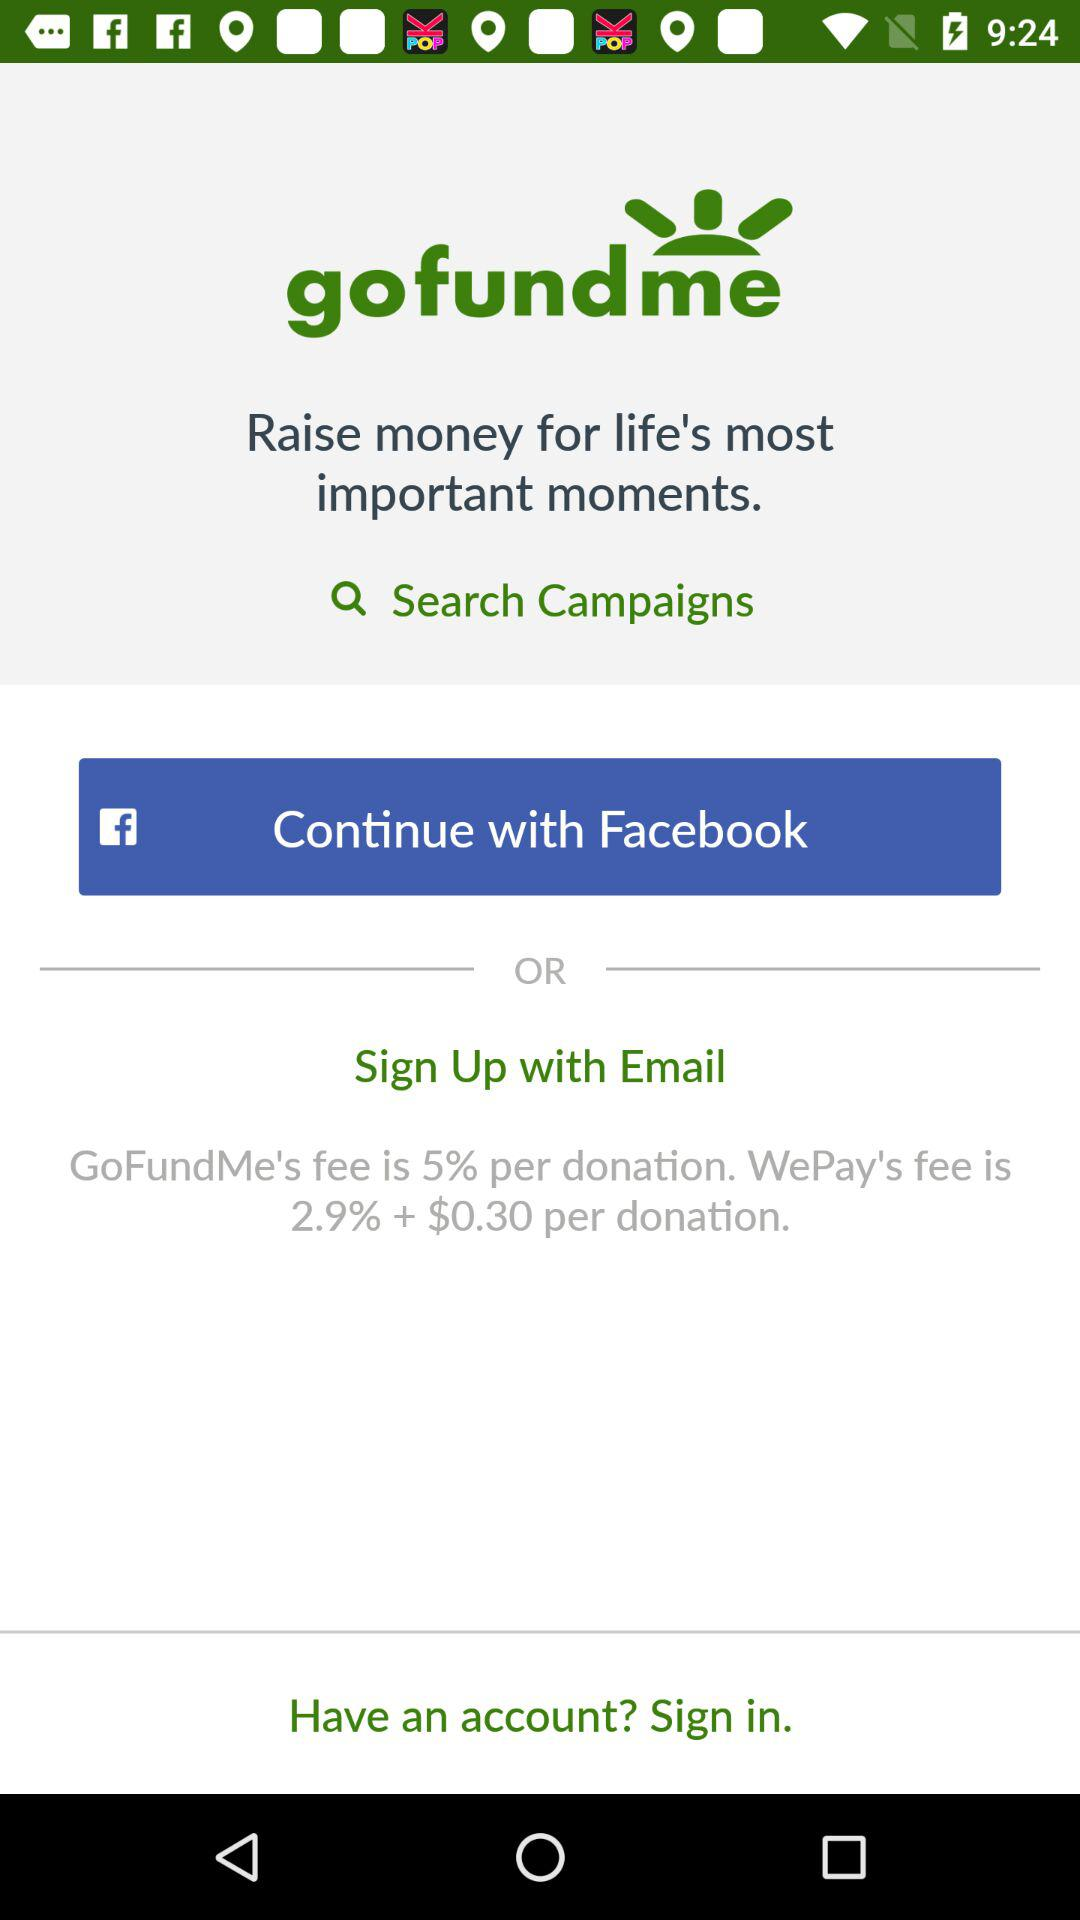How much is the fee of "GoFundMe" per donation? The fee of "GoFundMe" is 5 percent per donation. 